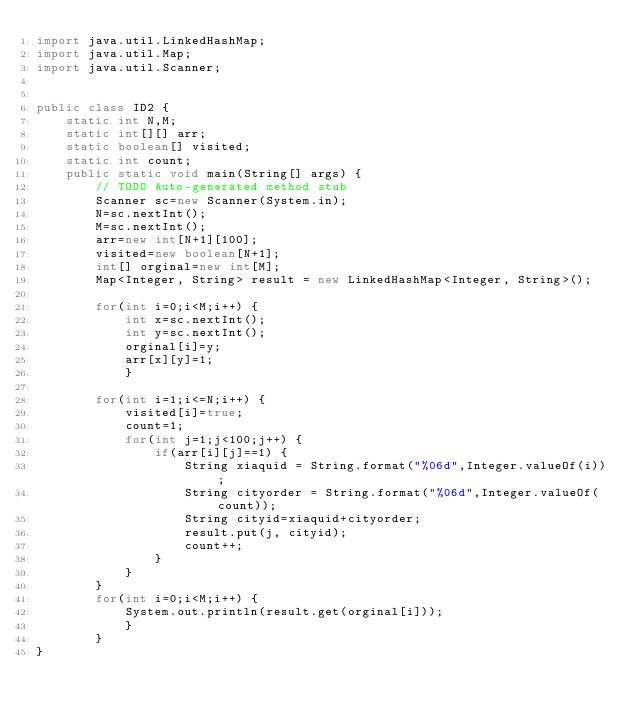Convert code to text. <code><loc_0><loc_0><loc_500><loc_500><_Java_>import java.util.LinkedHashMap;
import java.util.Map;
import java.util.Scanner;


public class ID2 {
	static int N,M;
	static int[][] arr;
	static boolean[] visited;
	static int count;
	public static void main(String[] args) {
		// TODO Auto-generated method stub
		Scanner sc=new Scanner(System.in);
		N=sc.nextInt();
		M=sc.nextInt();
		arr=new int[N+1][100];
		visited=new boolean[N+1];
		int[] orginal=new int[M];
		Map<Integer, String> result = new LinkedHashMap<Integer, String>();

		for(int i=0;i<M;i++) {
			int x=sc.nextInt();
			int y=sc.nextInt();
			orginal[i]=y;
			arr[x][y]=1;
			}
		
		for(int i=1;i<=N;i++) {
			visited[i]=true;
			count=1;
			for(int j=1;j<100;j++) {
				if(arr[i][j]==1) {
					String xiaquid = String.format("%06d",Integer.valueOf(i));
					String cityorder = String.format("%06d",Integer.valueOf(count));
					String cityid=xiaquid+cityorder;
					result.put(j, cityid);
					count++;
				}
			}
		}
		for(int i=0;i<M;i++) {
			System.out.println(result.get(orginal[i]));
			}
		}
}
</code> 